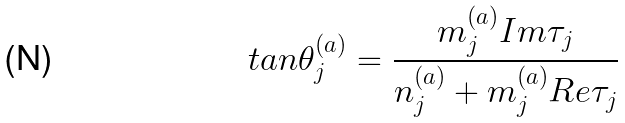<formula> <loc_0><loc_0><loc_500><loc_500>t a n \theta _ { j } ^ { ( a ) } = \frac { m _ { j } ^ { ( a ) } I m \tau _ { j } } { n _ { j } ^ { ( a ) } + m _ { j } ^ { ( a ) } R e \tau _ { j } }</formula> 